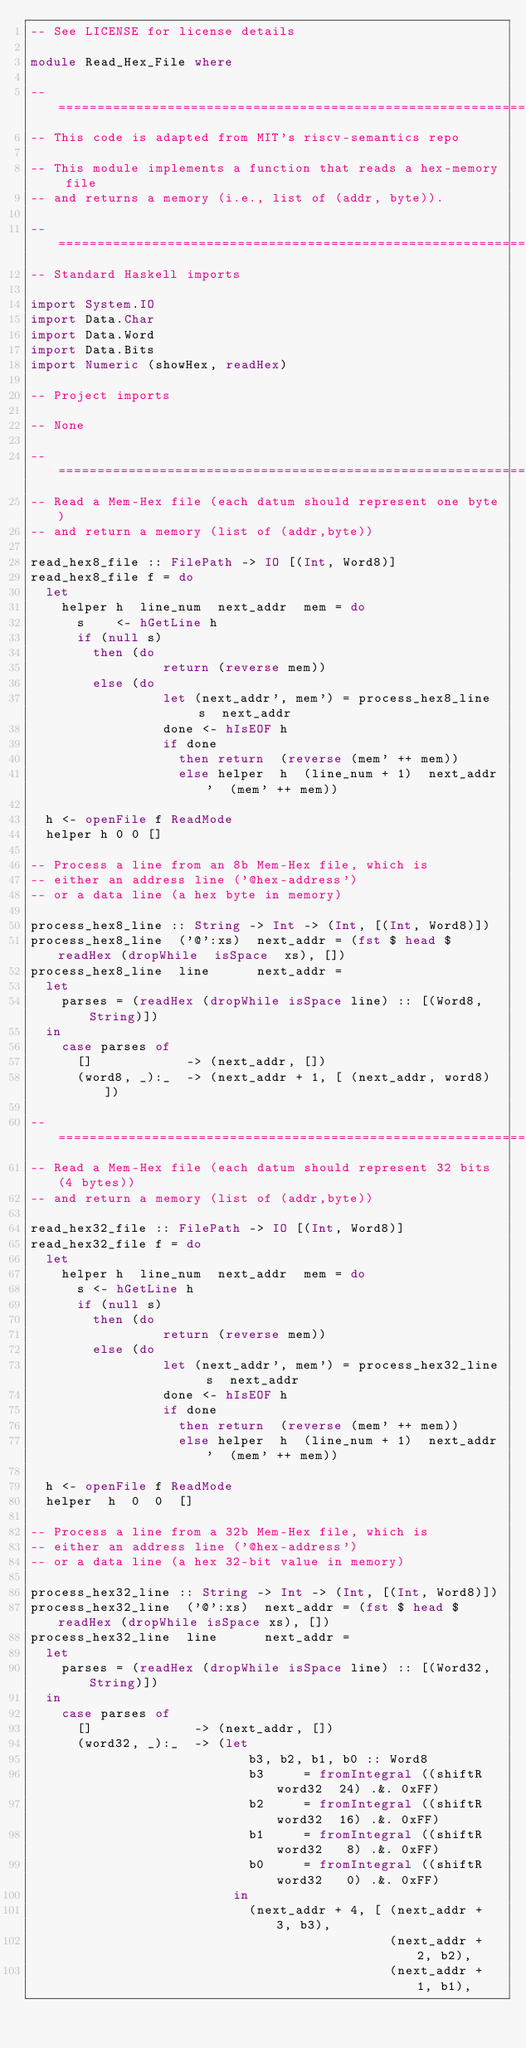<code> <loc_0><loc_0><loc_500><loc_500><_Haskell_>-- See LICENSE for license details

module Read_Hex_File where

-- ================================================================
-- This code is adapted from MIT's riscv-semantics repo

-- This module implements a function that reads a hex-memory file
-- and returns a memory (i.e., list of (addr, byte)).

-- ================================================================
-- Standard Haskell imports

import System.IO
import Data.Char
import Data.Word
import Data.Bits
import Numeric (showHex, readHex)

-- Project imports

-- None

-- ================================================================
-- Read a Mem-Hex file (each datum should represent one byte)
-- and return a memory (list of (addr,byte))

read_hex8_file :: FilePath -> IO [(Int, Word8)]
read_hex8_file f = do
  let
    helper h  line_num  next_addr  mem = do
      s    <- hGetLine h
      if (null s)
        then (do
                 return (reverse mem))
        else (do
                 let (next_addr', mem') = process_hex8_line  s  next_addr
                 done <- hIsEOF h
                 if done
                   then return  (reverse (mem' ++ mem))
                   else helper  h  (line_num + 1)  next_addr'  (mem' ++ mem))

  h <- openFile f ReadMode
  helper h 0 0 []

-- Process a line from an 8b Mem-Hex file, which is
-- either an address line ('@hex-address')
-- or a data line (a hex byte in memory)

process_hex8_line :: String -> Int -> (Int, [(Int, Word8)])
process_hex8_line  ('@':xs)  next_addr = (fst $ head $ readHex (dropWhile  isSpace  xs), [])
process_hex8_line  line      next_addr =
  let
    parses = (readHex (dropWhile isSpace line) :: [(Word8, String)])
  in
    case parses of
      []            -> (next_addr, [])
      (word8, _):_  -> (next_addr + 1, [ (next_addr, word8) ])

-- ================================================================
-- Read a Mem-Hex file (each datum should represent 32 bits (4 bytes))
-- and return a memory (list of (addr,byte))

read_hex32_file :: FilePath -> IO [(Int, Word8)]
read_hex32_file f = do
  let
    helper h  line_num  next_addr  mem = do
      s <- hGetLine h
      if (null s)
        then (do
                 return (reverse mem))
        else (do
                 let (next_addr', mem') = process_hex32_line  s  next_addr
                 done <- hIsEOF h
                 if done
                   then return  (reverse (mem' ++ mem))
                   else helper  h  (line_num + 1)  next_addr'  (mem' ++ mem))

  h <- openFile f ReadMode
  helper  h  0  0  []

-- Process a line from a 32b Mem-Hex file, which is
-- either an address line ('@hex-address')
-- or a data line (a hex 32-bit value in memory)

process_hex32_line :: String -> Int -> (Int, [(Int, Word8)])
process_hex32_line  ('@':xs)  next_addr = (fst $ head $ readHex (dropWhile isSpace xs), [])
process_hex32_line  line      next_addr =
  let
    parses = (readHex (dropWhile isSpace line) :: [(Word32, String)])
  in
    case parses of
      []             -> (next_addr, [])
      (word32, _):_  -> (let
                            b3, b2, b1, b0 :: Word8
                            b3     = fromIntegral ((shiftR  word32  24) .&. 0xFF)
                            b2     = fromIntegral ((shiftR  word32  16) .&. 0xFF)
                            b1     = fromIntegral ((shiftR  word32   8) .&. 0xFF)
                            b0     = fromIntegral ((shiftR  word32   0) .&. 0xFF)
                          in
                            (next_addr + 4, [ (next_addr + 3, b3),
                                              (next_addr + 2, b2),
                                              (next_addr + 1, b1),</code> 